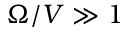<formula> <loc_0><loc_0><loc_500><loc_500>\Omega / V \gg 1</formula> 